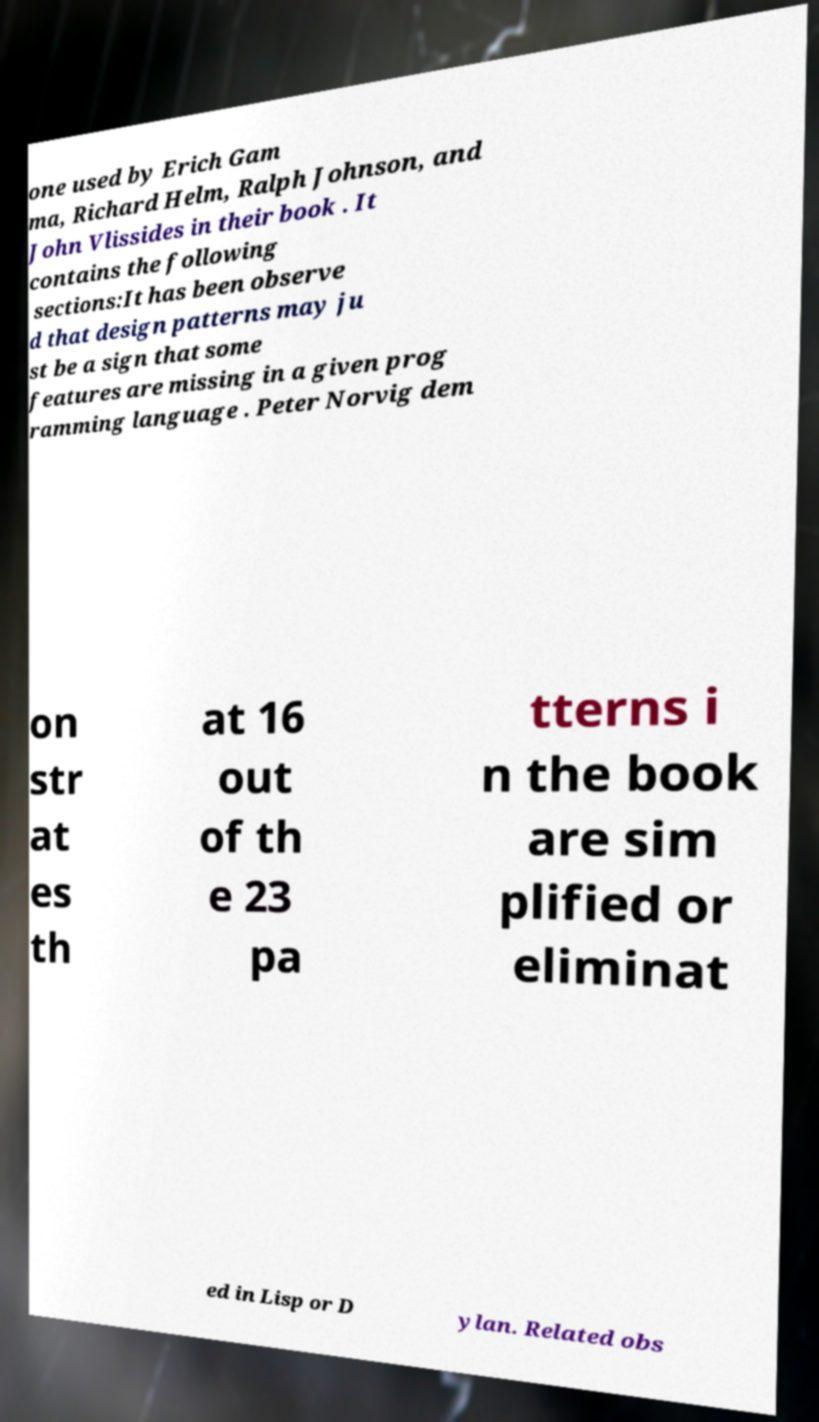Please read and relay the text visible in this image. What does it say? one used by Erich Gam ma, Richard Helm, Ralph Johnson, and John Vlissides in their book . It contains the following sections:It has been observe d that design patterns may ju st be a sign that some features are missing in a given prog ramming language . Peter Norvig dem on str at es th at 16 out of th e 23 pa tterns i n the book are sim plified or eliminat ed in Lisp or D ylan. Related obs 